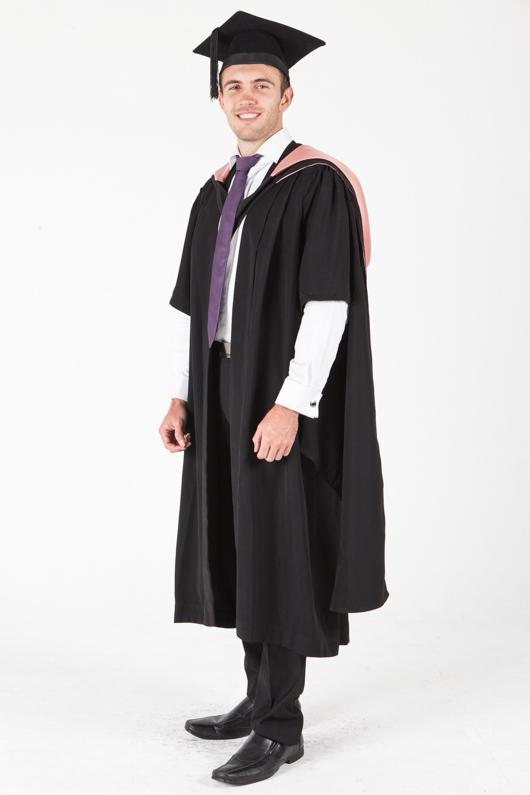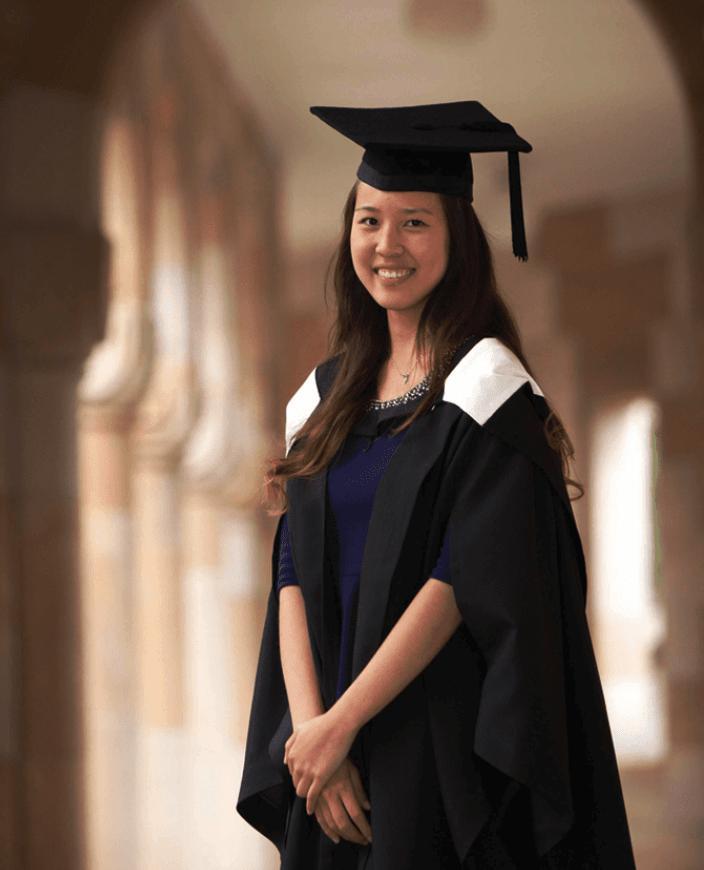The first image is the image on the left, the second image is the image on the right. Considering the images on both sides, is "The graduate attire in both images incorporate shades of red." valid? Answer yes or no. No. The first image is the image on the left, the second image is the image on the right. Assess this claim about the two images: "Each graduate model wears a black robe and a square-topped black hat with black tassel, but one model is a dark-haired girl and the other is a young man wearing a purple necktie.". Correct or not? Answer yes or no. Yes. 